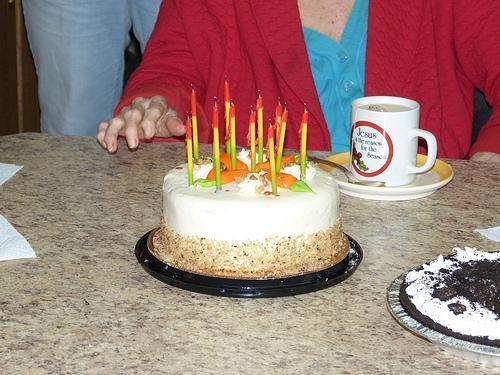How many mugs are there?
Give a very brief answer. 1. 